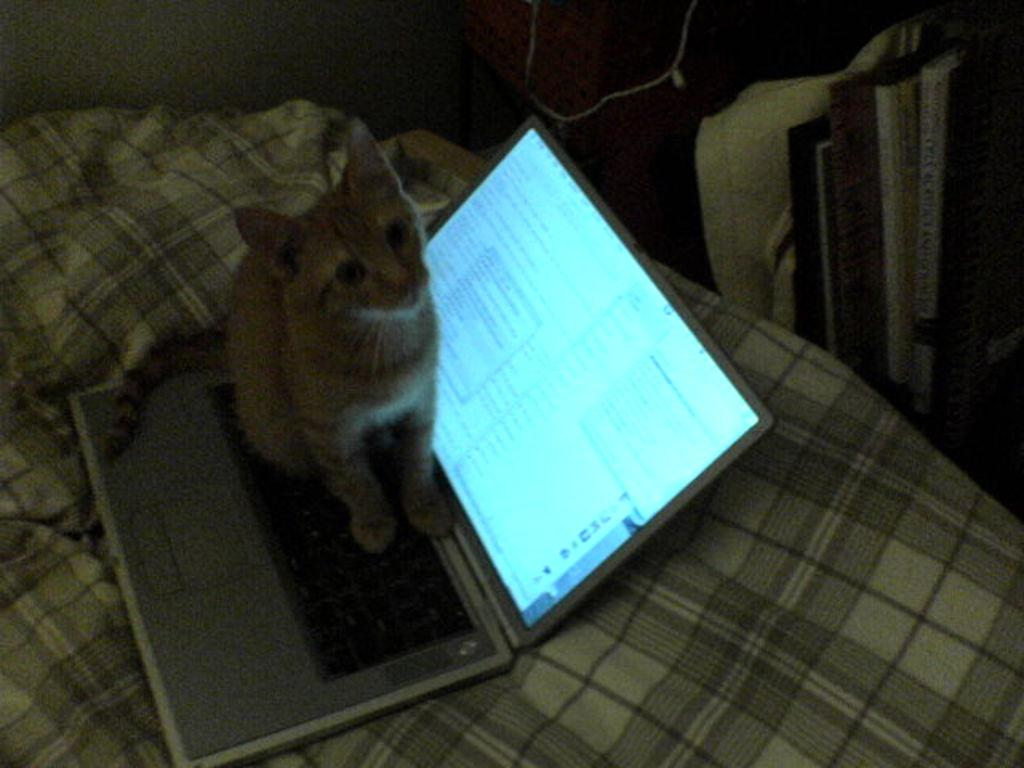What type of animal is in the image? There is a cat in the image. What is the cat standing on? The cat is standing on a laptop. Where is the laptop located? The laptop is on a bed. What can be seen on the right side of the image? There are books and files on the right side of the image. What does the mom say about the bomb in the image? There is no mention of a mom or a bomb in the image; it features a cat standing on a laptop on a bed, with books and files on the right side. 